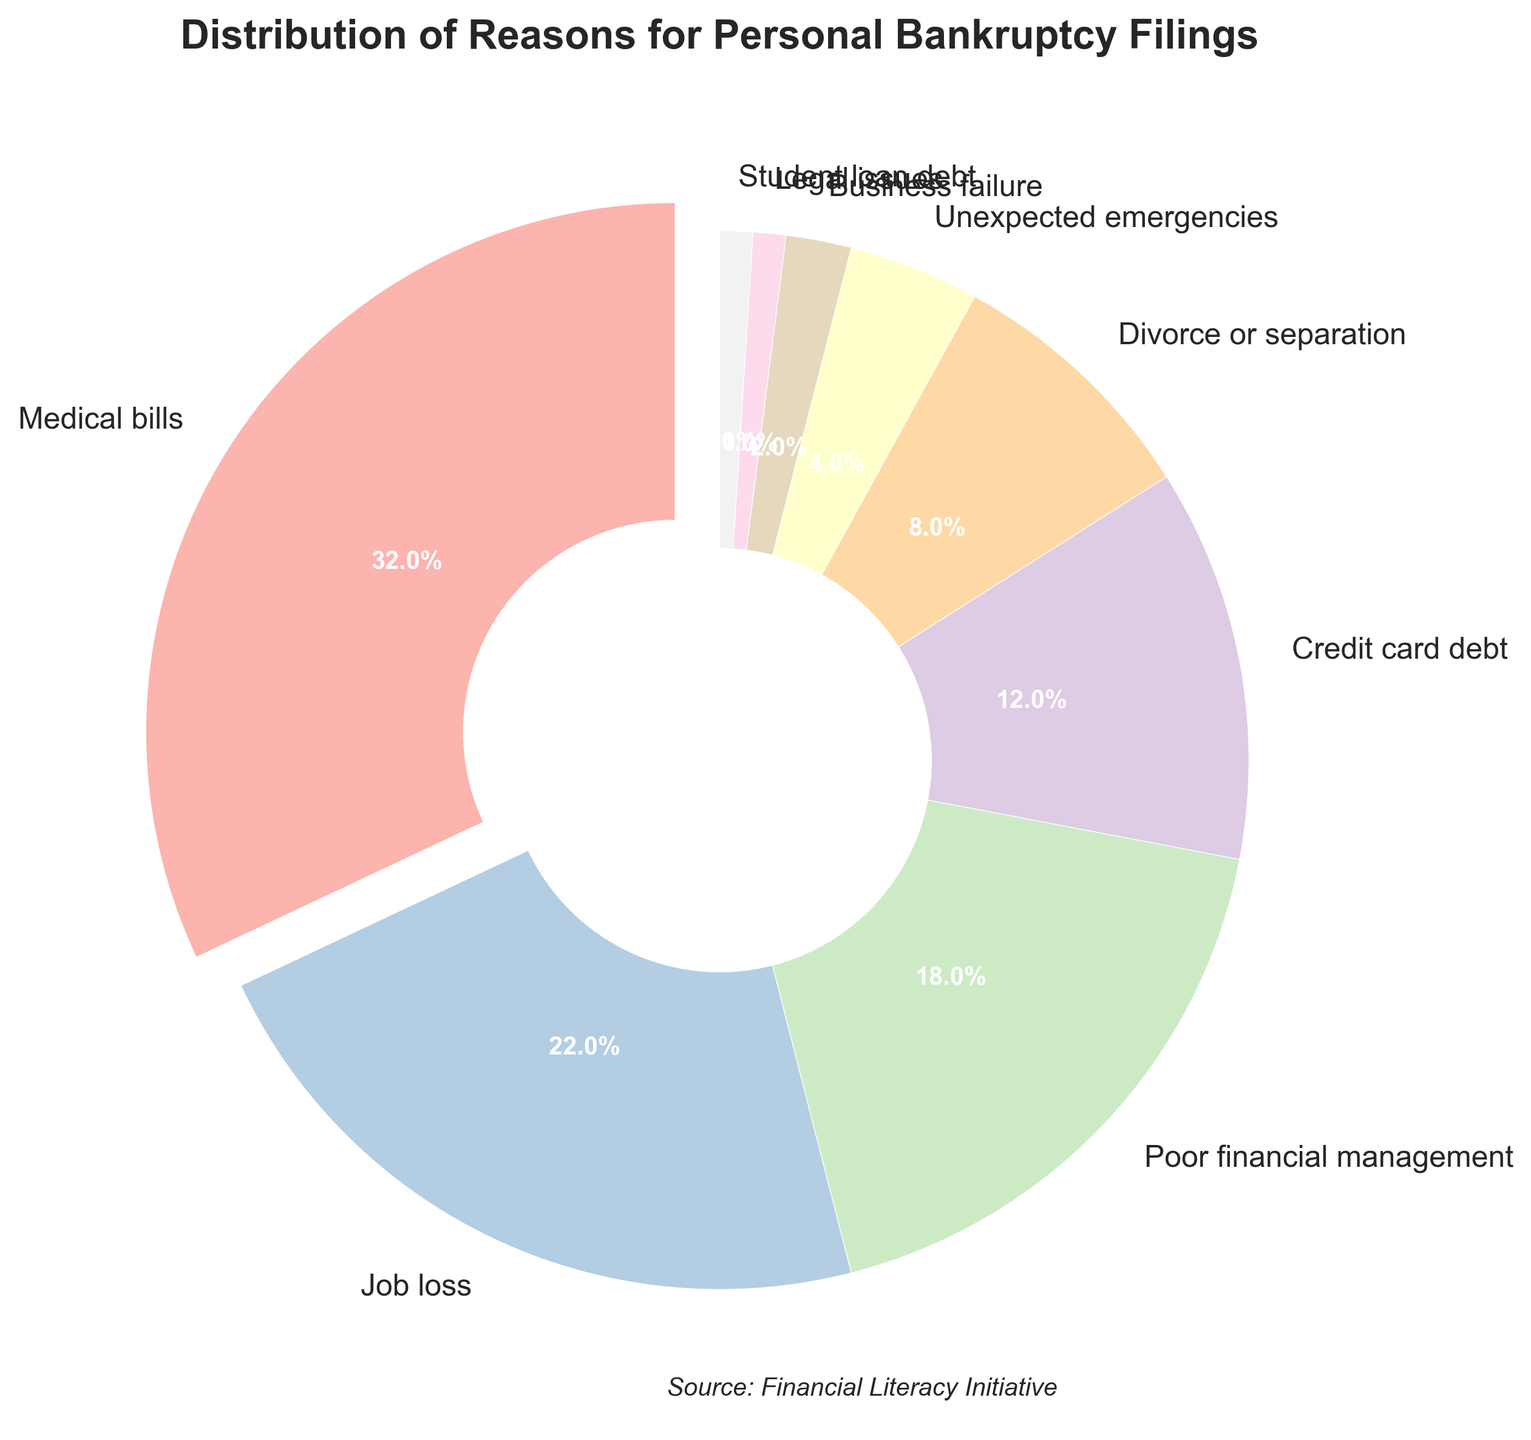What percentage of personal bankruptcy filings are attributed to medical bills? The slice representing medical bills on the pie chart has a label indicating its percentage. From the figure, the label associated with medical bills shows 32%.
Answer: 32% Which reason contributes the least to personal bankruptcy filings? To determine the smallest contribution, we examine all slices to find the one with the smallest percentage label. According to the pie chart, legal issues and student loan debt both have the smallest percentage at 1%.
Answer: Legal issues and student loan debt What is the combined percentage of personal bankruptcy filings due to job loss and poor financial management? Adding the percentages for job loss and poor financial management requires finding their respective labels on the chart and summing them. Job loss is 22%, and poor financial management is 18%. Their sum is 22% + 18% = 40%.
Answer: 40% Is the percentage of filings due to credit card debt greater than those due to divorce or separation? Comparing the slices for credit card debt and divorce or separation by examining their labels. Credit card debt is labeled 12%, and divorce or separation is labeled 8%. 12% is indeed greater than 8%.
Answer: Yes What is the difference in percentage between filings due to unexpected emergencies and business failure? The difference is calculated by subtracting the smaller percentage from the larger one. Unexpected emergencies have a percentage of 4%, while business failure has 2%. Therefore, 4% - 2% = 2%.
Answer: 2% Which reason has a larger percentage: unexpected emergencies or student loan debt? By comparing the percentages, unexpected emergencies have a percentage of 4% while student loan debt is 1%. Since 4% is greater than 1%, unexpected emergencies have a larger percentage.
Answer: Unexpected emergencies How many reasons have a percentage below 5%? Identifying slices with percentages below 5%, we count the reasons: unexpected emergencies (4%), business failure (2%), legal issues (1%), and student loan debt (1%). There are 4 reasons in total.
Answer: 4 If medical bills account for 32% of the filings, what fraction of the bankruptcies are due to other reasons? The percentage not due to medical bills is 100% - 32%. This equals 68%. To find the fraction, convert 68% to a fraction: 68/100 = 17/25 when simplified.
Answer: 17/25 